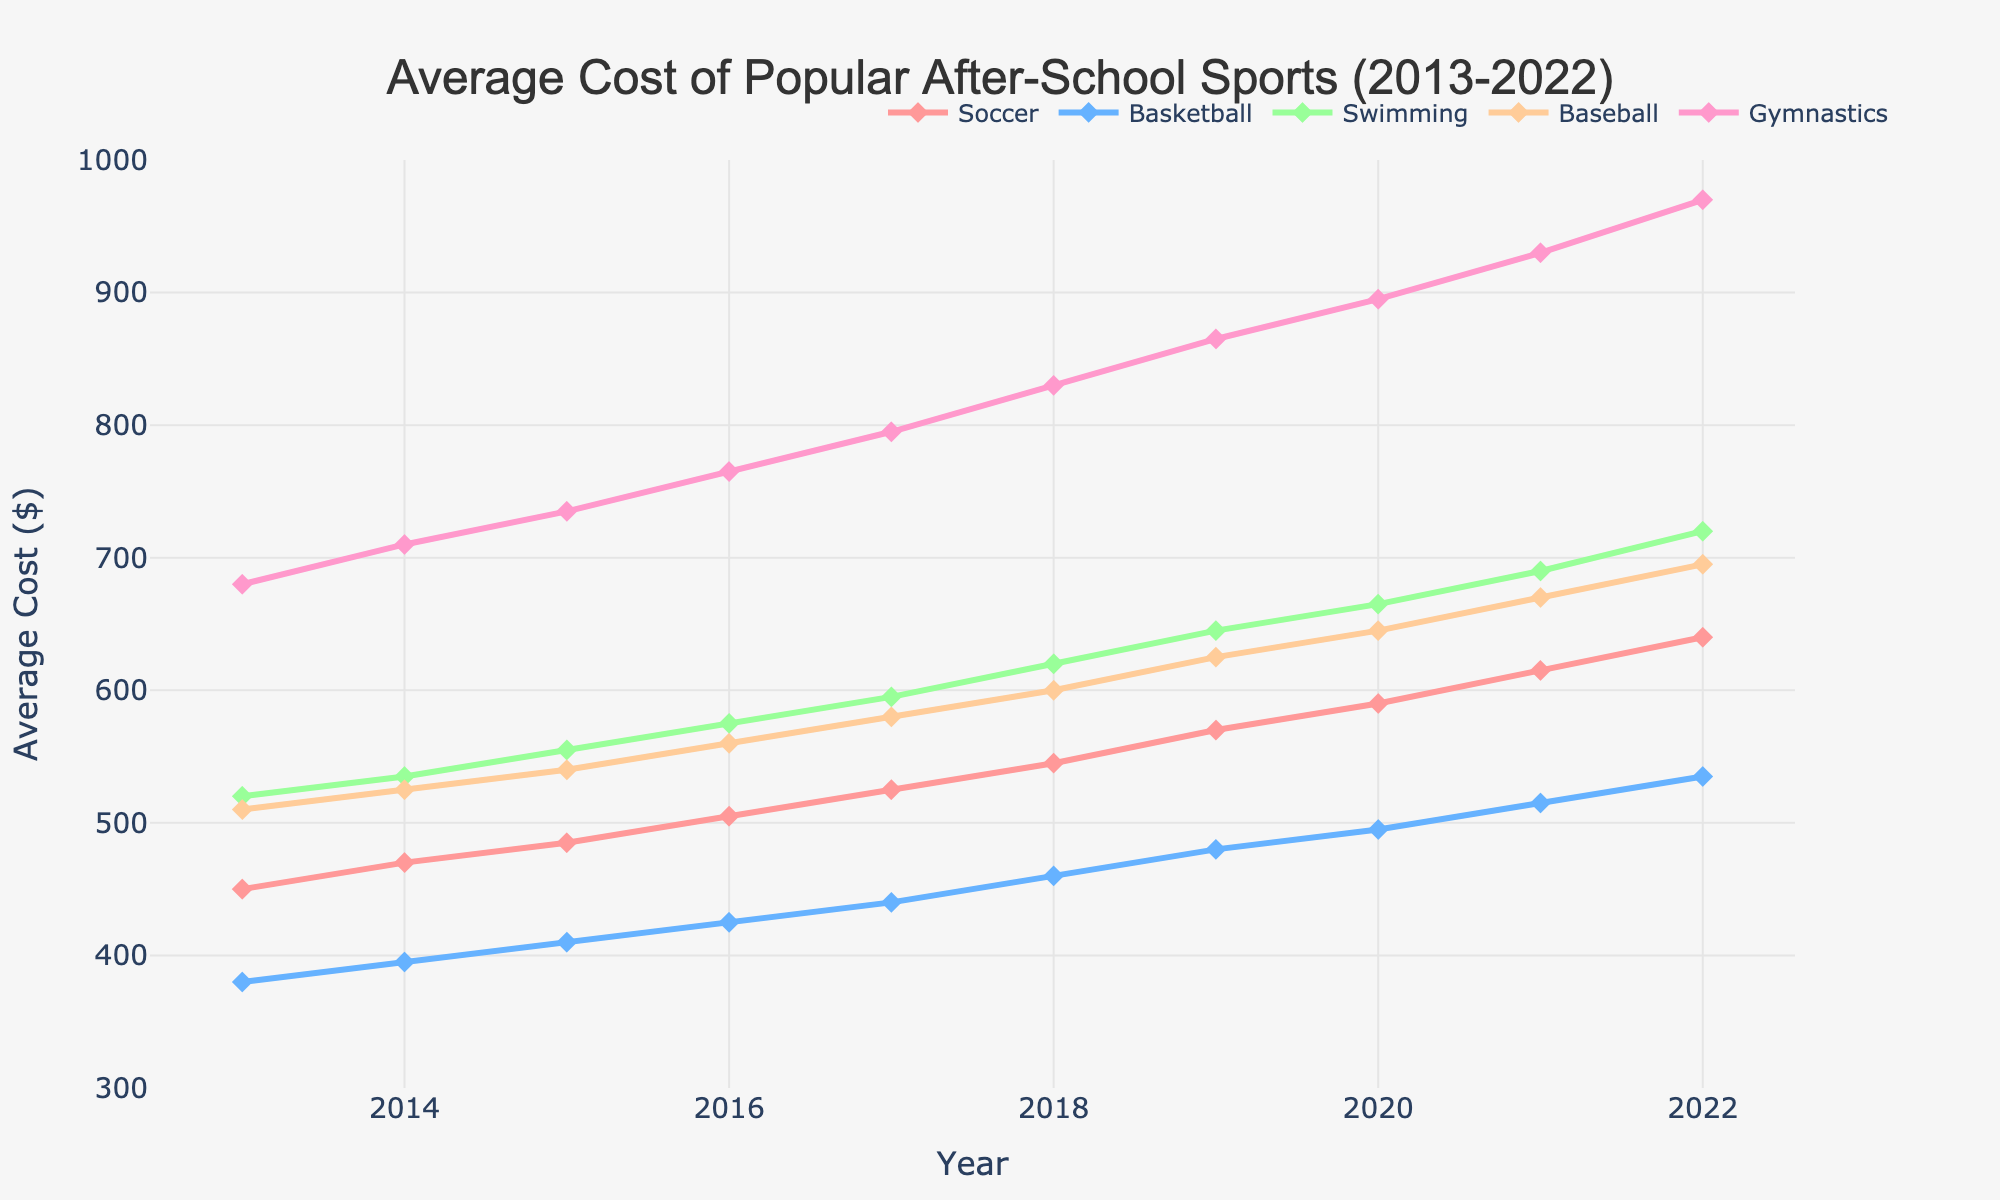What is the average cost of Soccer in 2013 and 2022? The cost of Soccer in 2013 is $450 and in 2022 it is $640. To find the average: (450 + 640) / 2 = 545
Answer: 545 Which sport had the highest cost in 2022? In 2022, Gymnastics had the highest cost at $970, visible as the highest point on the 2022 vertical line.
Answer: Gymnastics Between which years did the cost of Baseball have the greatest increase? By observing the Baseball line, the steepest incline occurs between 2021 ($670) and 2022 ($695). The increase is $695 - $670 = $25.
Answer: 2021-2022 What is the general trend in the cost of Swimming over the past decade? The line representing Swimming steadily increases from $520 in 2013 to $720 in 2022, indicating a consistent upward trend.
Answer: Upward trend Which sport experienced the smallest overall cost increase from 2013 to 2022? By comparing initial and final values for each sport, Basketball increased the least, from $380 in 2013 to $535 in 2022, a difference of $155.
Answer: Basketball How much more expensive was Gymnastics compared to Soccer in 2020? Gymnastics in 2020 cost $895 and Soccer cost $590. The difference is $895 - $590 = $305.
Answer: $305 In what year did Basketball surpass a $500 average cost? The Basketball line crosses the $500 mark between 2020 and 2021; hence, in 2021 it surpassed $500, marked at $515.
Answer: 2021 Did the cost of Swimming ever drop during the observed period? By looking at the Swimming line, there are no downward slopes; the cost increased every year without any drops.
Answer: No Which two sports showed the most similar trends in cost increase? By analyzing the slopes, Soccer and Baseball show similar incremental increases over the years, with no abrupt changes.
Answer: Soccer and Baseball 